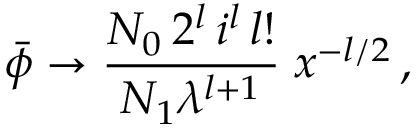<formula> <loc_0><loc_0><loc_500><loc_500>\bar { \phi } \rightarrow \frac { N _ { 0 } \, 2 ^ { l } \, i ^ { l } \, l ! } { N _ { 1 } \lambda ^ { l + 1 } } \, x ^ { - l / 2 } \, ,</formula> 